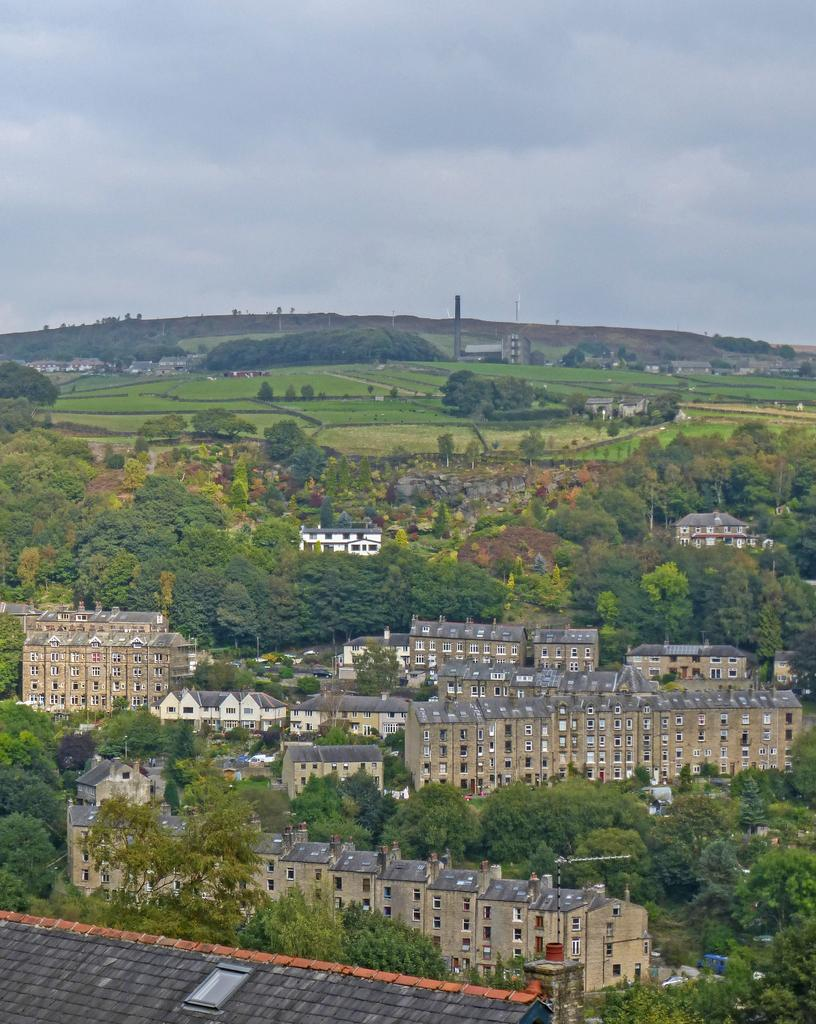What type of structures can be seen on the land in the image? There are buildings on the land in the image. What type of vegetation is present in the image? Trees are present in the image. What is the natural landscape visible in the image? There is a grassland visible in the image. What is visible in the sky in the image? The sky is visible in the image, and clouds are present. How many planes are being cared for by the stick in the image? There are no planes or sticks present in the image. 